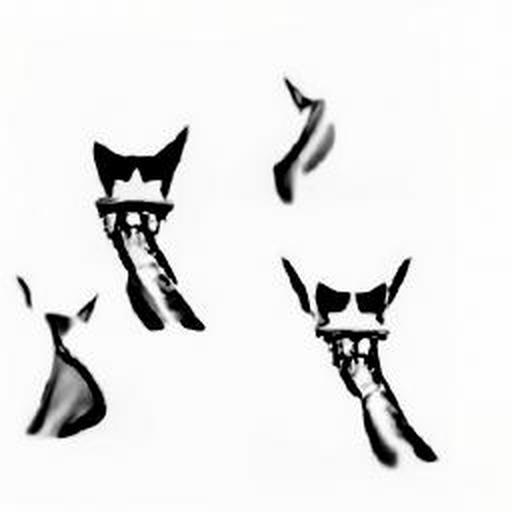Are the subject lines slightly blurry? Yes, the subject lines in the image appear slightly blurry, likely due to the artistic effect called bokeh, which gives the image a soft, out-of-focus quality and helps to draw attention to certain elements within the frame. 